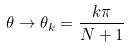<formula> <loc_0><loc_0><loc_500><loc_500>\theta \to \theta _ { k } = \frac { k \pi } { N + 1 }</formula> 